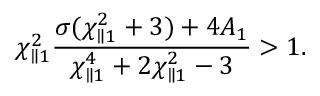Convert formula to latex. <formula><loc_0><loc_0><loc_500><loc_500>\chi _ { \| 1 } ^ { 2 } \frac { \sigma ( \chi _ { \| 1 } ^ { 2 } + 3 ) + 4 A _ { 1 } } { \chi _ { \| 1 } ^ { 4 } + 2 \chi _ { \| 1 } ^ { 2 } - 3 } > 1 .</formula> 